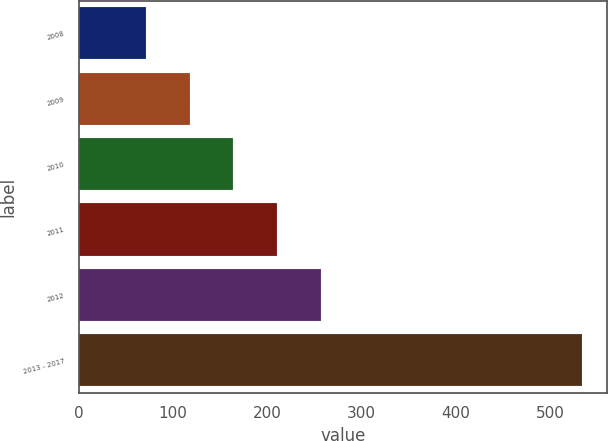Convert chart to OTSL. <chart><loc_0><loc_0><loc_500><loc_500><bar_chart><fcel>2008<fcel>2009<fcel>2010<fcel>2011<fcel>2012<fcel>2013 - 2017<nl><fcel>72<fcel>118.2<fcel>164.4<fcel>210.6<fcel>256.8<fcel>534<nl></chart> 